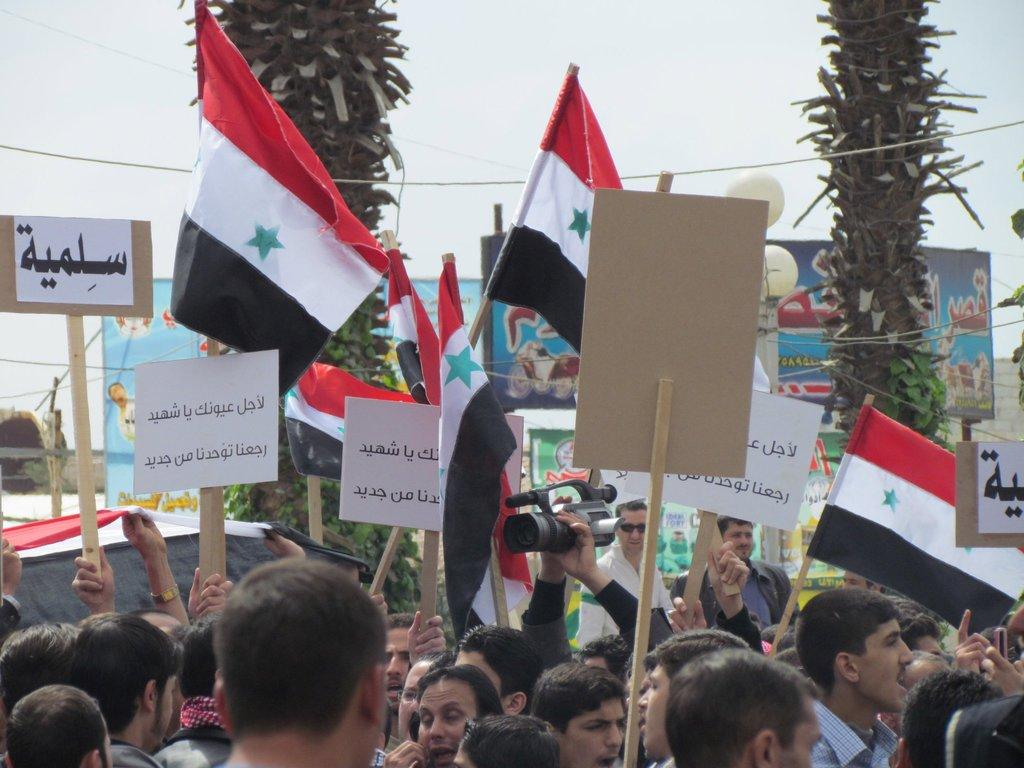Who or what can be seen in the image? There are people in the image. What can be seen besides the people? There are flags, name boards, a camera, and other objects in the image. What is visible in the background of the image? There are trees and the sky visible in the background of the image. What type of banana is being produced in the image? There is no banana or any reference to producing anything in the image. 